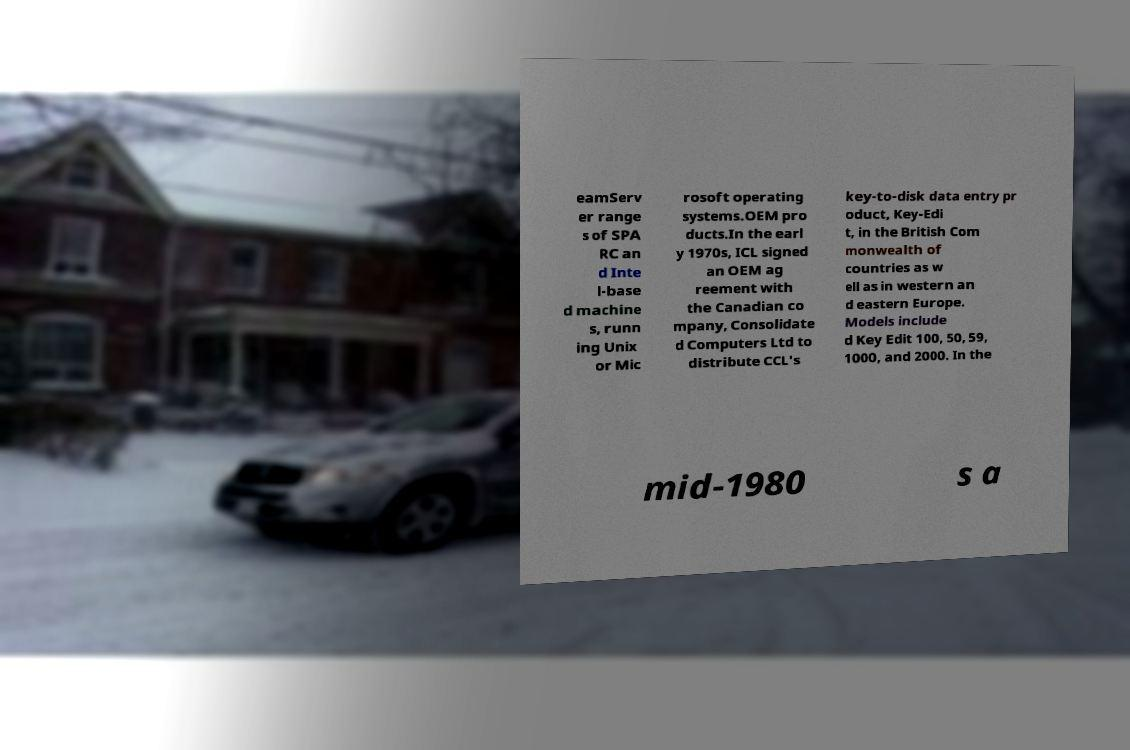What messages or text are displayed in this image? I need them in a readable, typed format. eamServ er range s of SPA RC an d Inte l-base d machine s, runn ing Unix or Mic rosoft operating systems.OEM pro ducts.In the earl y 1970s, ICL signed an OEM ag reement with the Canadian co mpany, Consolidate d Computers Ltd to distribute CCL's key-to-disk data entry pr oduct, Key-Edi t, in the British Com monwealth of countries as w ell as in western an d eastern Europe. Models include d Key Edit 100, 50, 59, 1000, and 2000. In the mid-1980 s a 